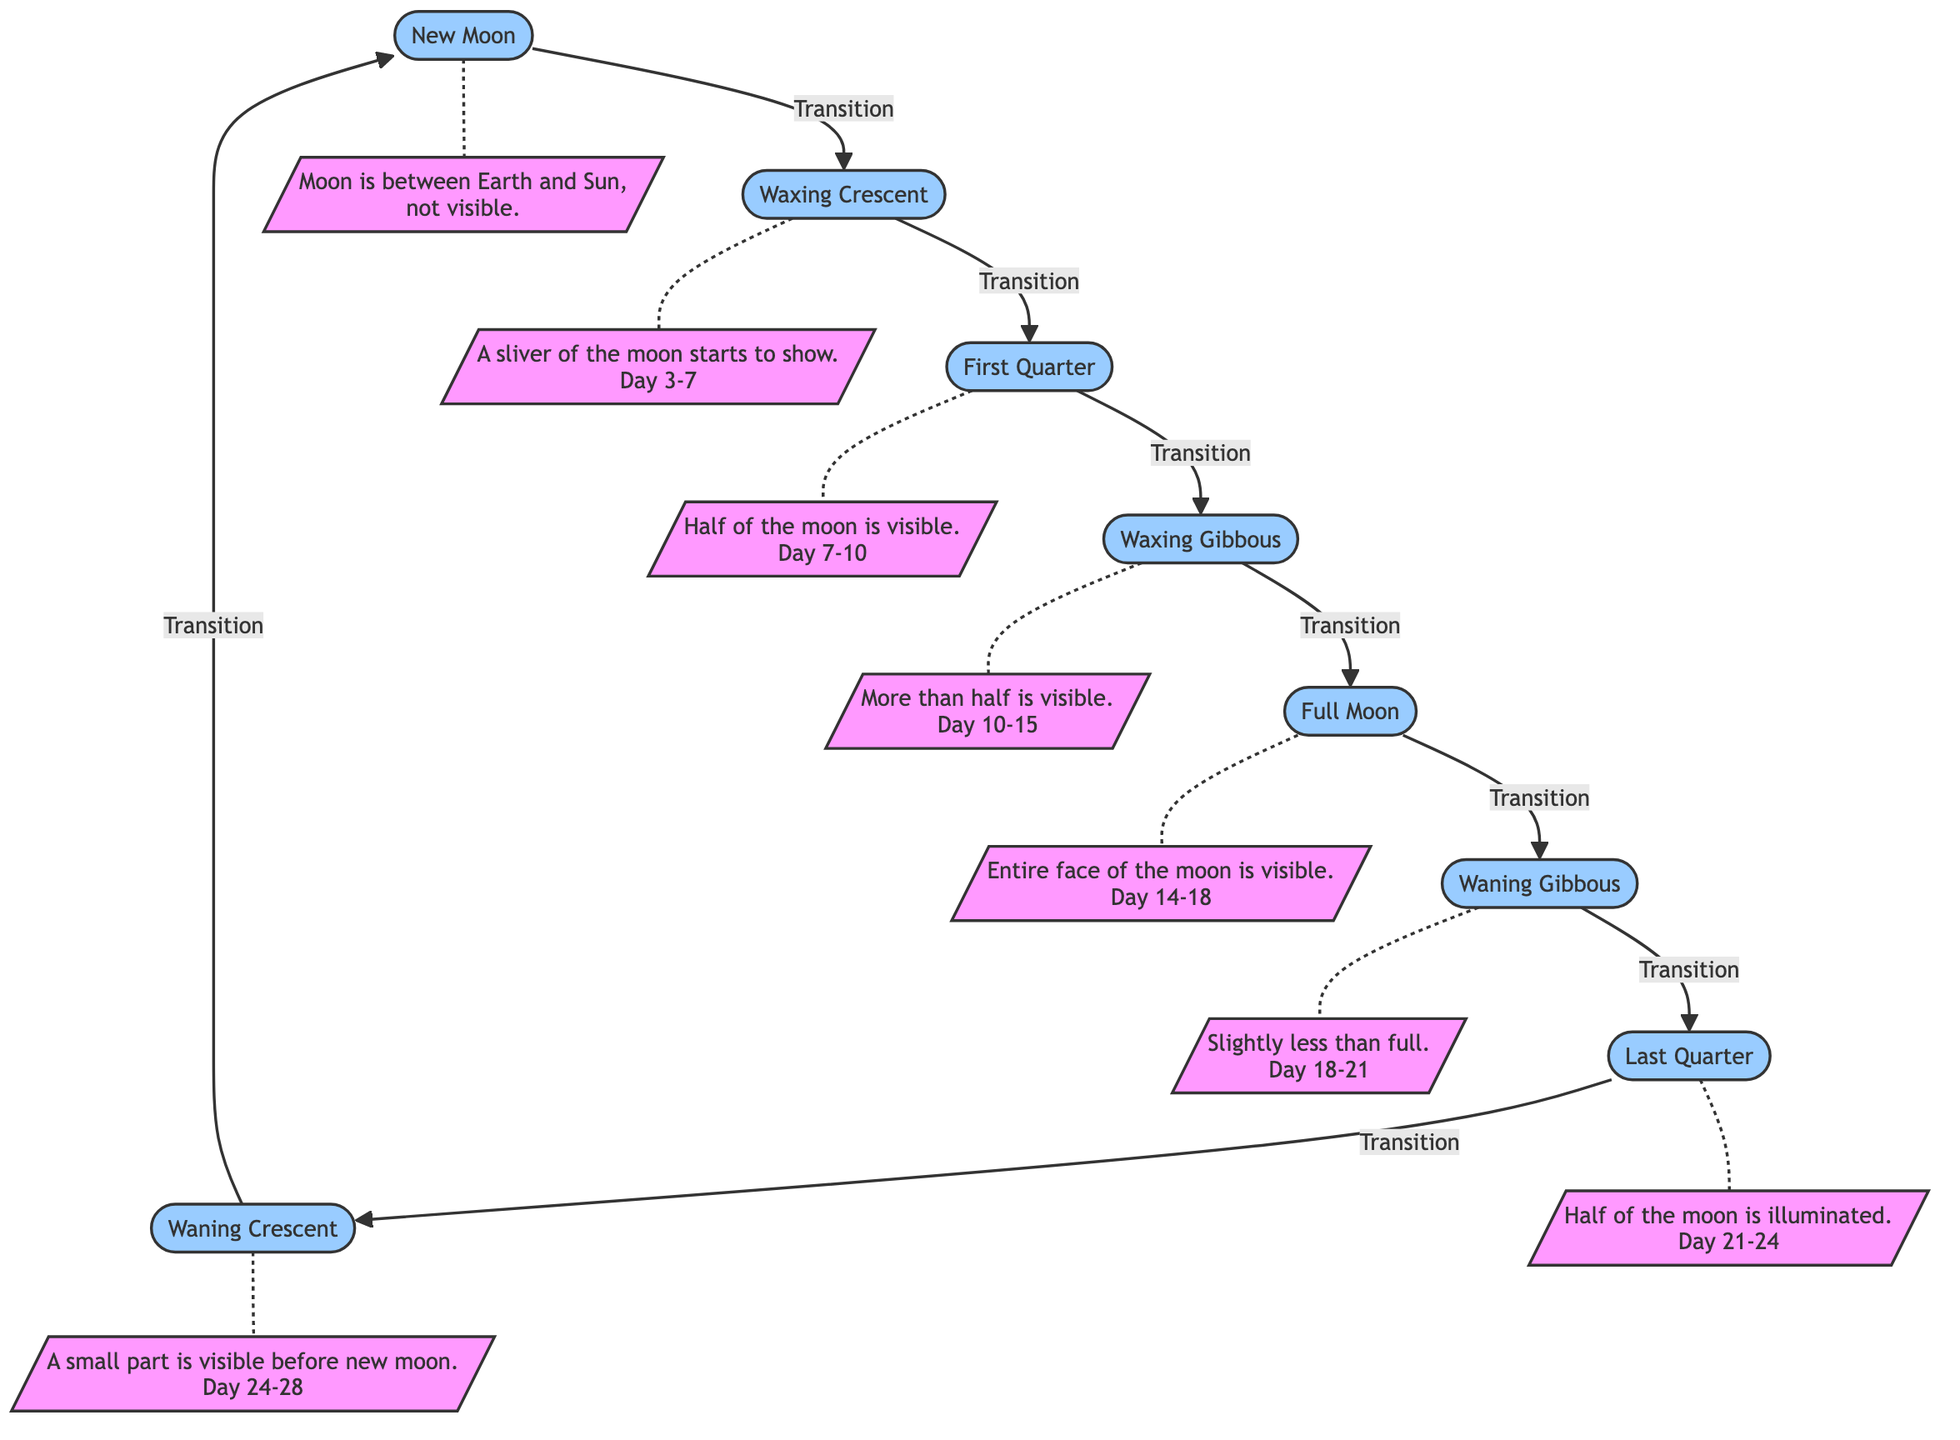What is the first phase of the moon? The diagram starts with the "New Moon" node, indicating it is the first phase in the lunar cycle.
Answer: New Moon How many total phases are depicted in the diagram? Counting each distinct phase node, there are eight phases from New Moon to Waning Crescent.
Answer: 8 Which phase comes after the First Quarter? By following the flow from the "First Quarter" node, the next phase is "Waxing Gibbous."
Answer: Waxing Gibbous What day range corresponds to the Full Moon? The description connected to the "Full Moon" node states it is visible during "Day 14-18."
Answer: Day 14-18 What is the visibility status of the Waxing Crescent phase? The description for "Waxing Crescent" mentions "A sliver of the moon starts to show," indicating partial visibility.
Answer: A sliver of the moon starts to show In which phase is the moon completely visible? The diagram indicates that the "Full Moon" phase is when the entire face of the moon is visible.
Answer: Full Moon What is the relationship between the Waning Gibbous and the Last Quarter phases? By following the transitions, "Waning Gibbous" flows directly into "Last Quarter," indicating they are sequential phases.
Answer: Sequential phases How many days does the Waning Crescent last? The "Waning Crescent" phase description shows "Day 24-28," indicating it lasts for 4 days.
Answer: 4 days What is the key change in visibility from Full Moon to Waning Gibbous? The transition description indicates that after the Full Moon, "Slightly less than full" describes the visibility in the Waning Gibbous phase.
Answer: Slightly less than full 